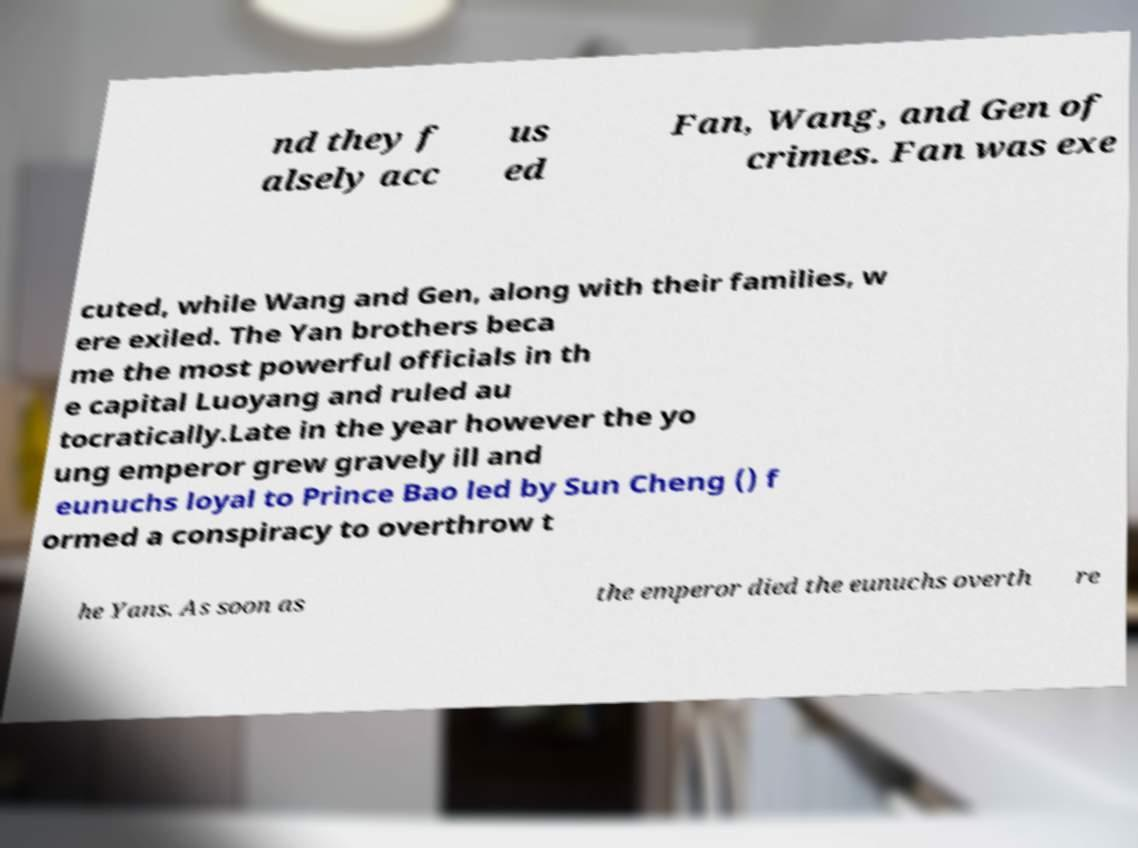Could you extract and type out the text from this image? nd they f alsely acc us ed Fan, Wang, and Gen of crimes. Fan was exe cuted, while Wang and Gen, along with their families, w ere exiled. The Yan brothers beca me the most powerful officials in th e capital Luoyang and ruled au tocratically.Late in the year however the yo ung emperor grew gravely ill and eunuchs loyal to Prince Bao led by Sun Cheng () f ormed a conspiracy to overthrow t he Yans. As soon as the emperor died the eunuchs overth re 